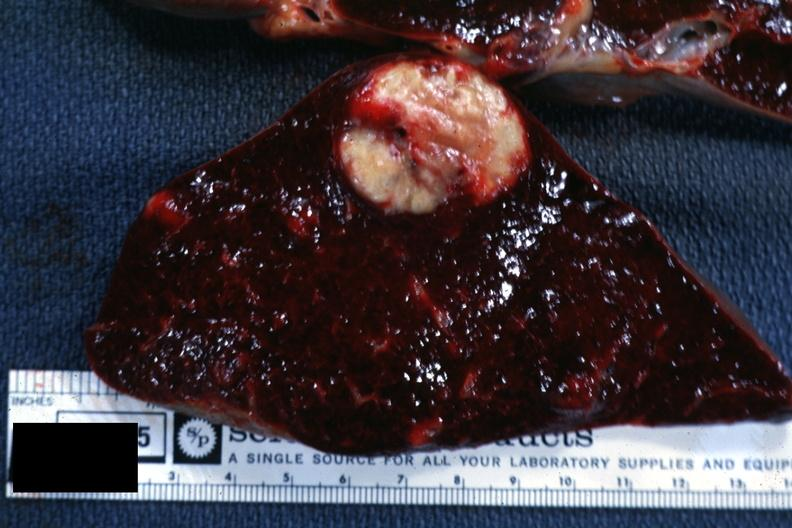what is present?
Answer the question using a single word or phrase. Metastatic carcinoma 